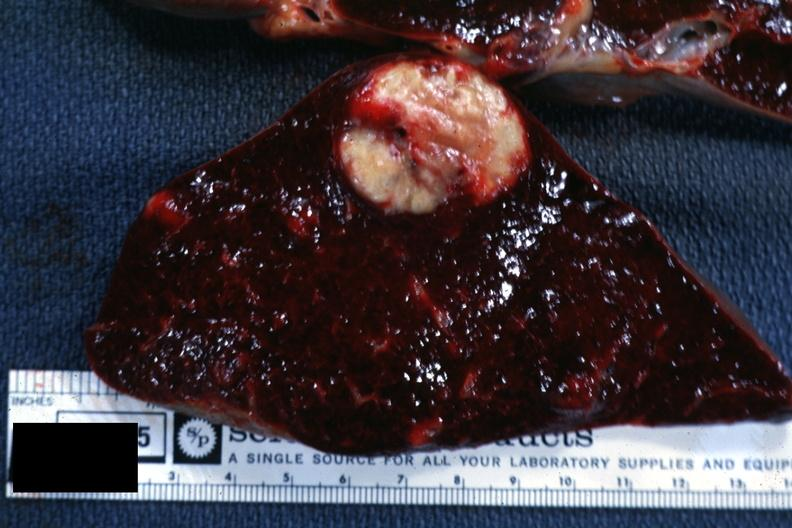what is present?
Answer the question using a single word or phrase. Metastatic carcinoma 